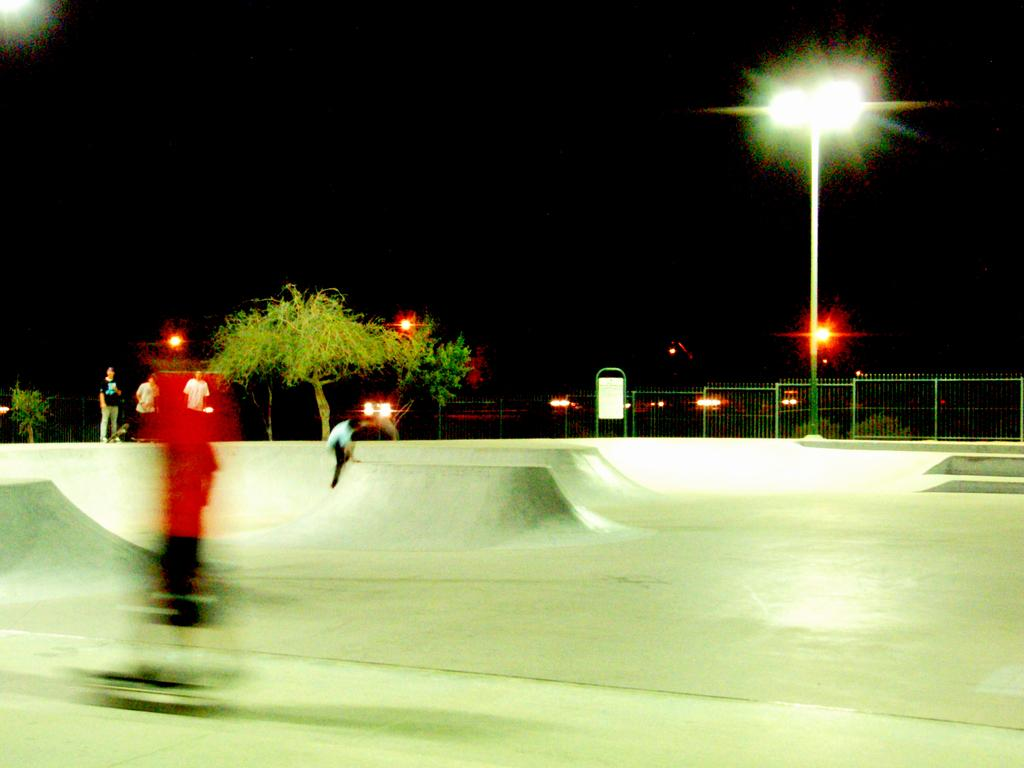What are the two people in the image doing? The two people in the image are skating. What is behind the skaters in the image? There is a railing behind the skaters in the image. What can be seen attached to a pole in the image? There is a light attached to a pole in the image. What type of vegetation is present in the image? There is a tree in the image. What is visible in the background of the image? The sky is visible in the background of the image. Can you tell me how many police officers are interacting with the stranger in the image? There are no police officers or strangers present in the image; it features two people skating, a railing, a pole with a light, a tree, and the sky. 